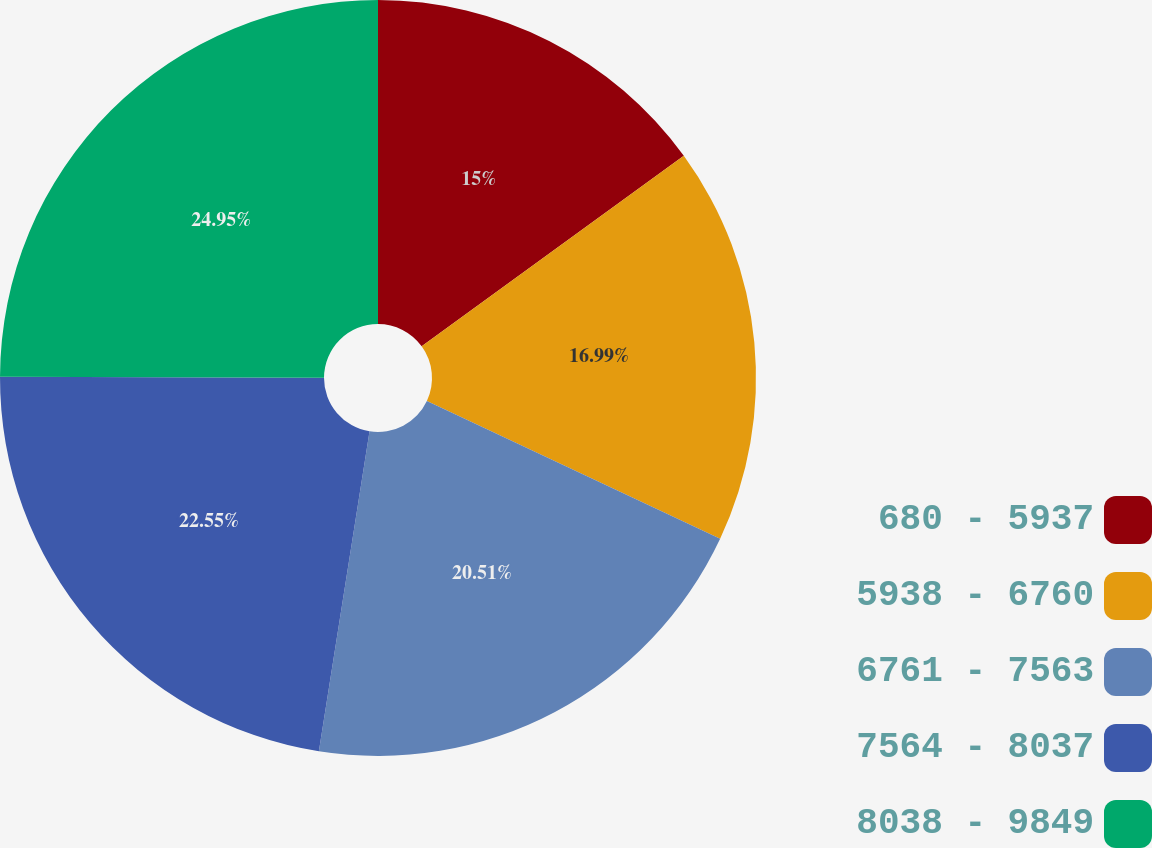Convert chart to OTSL. <chart><loc_0><loc_0><loc_500><loc_500><pie_chart><fcel>680 - 5937<fcel>5938 - 6760<fcel>6761 - 7563<fcel>7564 - 8037<fcel>8038 - 9849<nl><fcel>15.0%<fcel>16.99%<fcel>20.51%<fcel>22.55%<fcel>24.95%<nl></chart> 